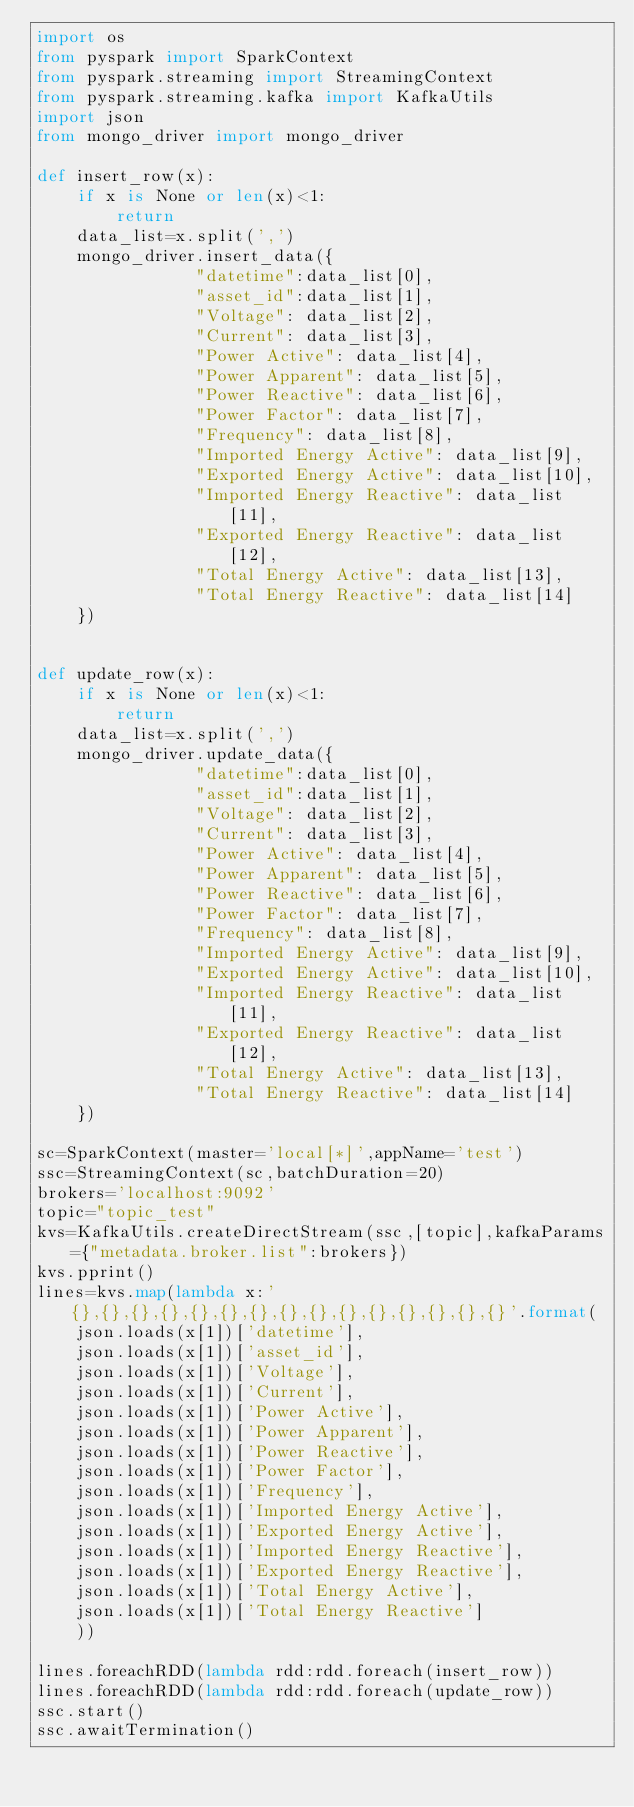<code> <loc_0><loc_0><loc_500><loc_500><_Python_>import os
from pyspark import SparkContext
from pyspark.streaming import StreamingContext
from pyspark.streaming.kafka import KafkaUtils
import json
from mongo_driver import mongo_driver

def insert_row(x):
    if x is None or len(x)<1:
        return
    data_list=x.split(',')
    mongo_driver.insert_data({
                "datetime":data_list[0],
                "asset_id":data_list[1],
                "Voltage": data_list[2],
                "Current": data_list[3],
                "Power Active": data_list[4],
                "Power Apparent": data_list[5],
                "Power Reactive": data_list[6],
                "Power Factor": data_list[7],
                "Frequency": data_list[8],
                "Imported Energy Active": data_list[9],
                "Exported Energy Active": data_list[10],
                "Imported Energy Reactive": data_list[11],
                "Exported Energy Reactive": data_list[12],
                "Total Energy Active": data_list[13],
                "Total Energy Reactive": data_list[14]
    })


def update_row(x):
    if x is None or len(x)<1:
        return
    data_list=x.split(',')
    mongo_driver.update_data({
                "datetime":data_list[0],
                "asset_id":data_list[1],
                "Voltage": data_list[2],
                "Current": data_list[3],
                "Power Active": data_list[4],
                "Power Apparent": data_list[5],
                "Power Reactive": data_list[6],
                "Power Factor": data_list[7],
                "Frequency": data_list[8],
                "Imported Energy Active": data_list[9],
                "Exported Energy Active": data_list[10],
                "Imported Energy Reactive": data_list[11],
                "Exported Energy Reactive": data_list[12],
                "Total Energy Active": data_list[13],
                "Total Energy Reactive": data_list[14]
    })

sc=SparkContext(master='local[*]',appName='test')
ssc=StreamingContext(sc,batchDuration=20)
brokers='localhost:9092'
topic="topic_test"
kvs=KafkaUtils.createDirectStream(ssc,[topic],kafkaParams={"metadata.broker.list":brokers})
kvs.pprint()
lines=kvs.map(lambda x:'{},{},{},{},{},{},{},{},{},{},{},{},{},{},{}'.format(
    json.loads(x[1])['datetime'],
    json.loads(x[1])['asset_id'],
    json.loads(x[1])['Voltage'],
    json.loads(x[1])['Current'],
    json.loads(x[1])['Power Active'],
    json.loads(x[1])['Power Apparent'],
    json.loads(x[1])['Power Reactive'],
    json.loads(x[1])['Power Factor'],
    json.loads(x[1])['Frequency'],
    json.loads(x[1])['Imported Energy Active'],
    json.loads(x[1])['Exported Energy Active'],
    json.loads(x[1])['Imported Energy Reactive'],
    json.loads(x[1])['Exported Energy Reactive'],
    json.loads(x[1])['Total Energy Active'],
    json.loads(x[1])['Total Energy Reactive']
    ))

lines.foreachRDD(lambda rdd:rdd.foreach(insert_row))
lines.foreachRDD(lambda rdd:rdd.foreach(update_row))
ssc.start()
ssc.awaitTermination()</code> 